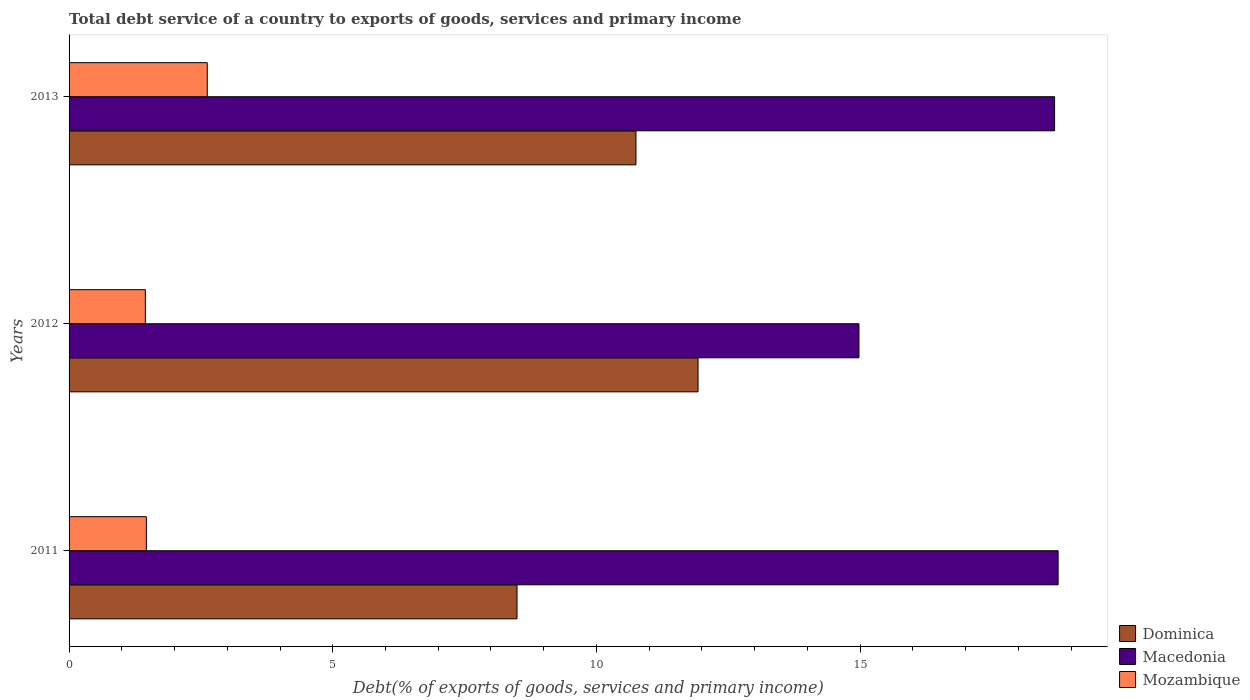How many different coloured bars are there?
Your answer should be very brief. 3. How many groups of bars are there?
Offer a very short reply. 3. Are the number of bars on each tick of the Y-axis equal?
Provide a succinct answer. Yes. What is the total debt service in Mozambique in 2011?
Offer a terse response. 1.47. Across all years, what is the maximum total debt service in Mozambique?
Offer a very short reply. 2.62. Across all years, what is the minimum total debt service in Dominica?
Your response must be concise. 8.49. In which year was the total debt service in Macedonia maximum?
Ensure brevity in your answer.  2011. What is the total total debt service in Mozambique in the graph?
Your answer should be very brief. 5.53. What is the difference between the total debt service in Dominica in 2011 and that in 2012?
Your answer should be compact. -3.43. What is the difference between the total debt service in Dominica in 2011 and the total debt service in Mozambique in 2012?
Your response must be concise. 7.05. What is the average total debt service in Macedonia per year?
Offer a terse response. 17.47. In the year 2013, what is the difference between the total debt service in Dominica and total debt service in Macedonia?
Your answer should be very brief. -7.94. What is the ratio of the total debt service in Macedonia in 2011 to that in 2012?
Ensure brevity in your answer.  1.25. Is the total debt service in Macedonia in 2011 less than that in 2013?
Offer a very short reply. No. Is the difference between the total debt service in Dominica in 2011 and 2013 greater than the difference between the total debt service in Macedonia in 2011 and 2013?
Provide a short and direct response. No. What is the difference between the highest and the second highest total debt service in Macedonia?
Give a very brief answer. 0.07. What is the difference between the highest and the lowest total debt service in Macedonia?
Keep it short and to the point. 3.78. Is the sum of the total debt service in Dominica in 2012 and 2013 greater than the maximum total debt service in Mozambique across all years?
Keep it short and to the point. Yes. What does the 1st bar from the top in 2012 represents?
Offer a very short reply. Mozambique. What does the 1st bar from the bottom in 2012 represents?
Offer a very short reply. Dominica. Are all the bars in the graph horizontal?
Provide a short and direct response. Yes. Are the values on the major ticks of X-axis written in scientific E-notation?
Keep it short and to the point. No. Does the graph contain any zero values?
Offer a very short reply. No. Does the graph contain grids?
Your answer should be very brief. No. How many legend labels are there?
Provide a short and direct response. 3. What is the title of the graph?
Give a very brief answer. Total debt service of a country to exports of goods, services and primary income. Does "Poland" appear as one of the legend labels in the graph?
Your response must be concise. No. What is the label or title of the X-axis?
Offer a terse response. Debt(% of exports of goods, services and primary income). What is the label or title of the Y-axis?
Provide a short and direct response. Years. What is the Debt(% of exports of goods, services and primary income) in Dominica in 2011?
Make the answer very short. 8.49. What is the Debt(% of exports of goods, services and primary income) of Macedonia in 2011?
Your response must be concise. 18.75. What is the Debt(% of exports of goods, services and primary income) of Mozambique in 2011?
Make the answer very short. 1.47. What is the Debt(% of exports of goods, services and primary income) in Dominica in 2012?
Give a very brief answer. 11.93. What is the Debt(% of exports of goods, services and primary income) of Macedonia in 2012?
Your response must be concise. 14.98. What is the Debt(% of exports of goods, services and primary income) in Mozambique in 2012?
Offer a very short reply. 1.45. What is the Debt(% of exports of goods, services and primary income) of Dominica in 2013?
Your answer should be compact. 10.75. What is the Debt(% of exports of goods, services and primary income) of Macedonia in 2013?
Your answer should be very brief. 18.69. What is the Debt(% of exports of goods, services and primary income) of Mozambique in 2013?
Your answer should be very brief. 2.62. Across all years, what is the maximum Debt(% of exports of goods, services and primary income) in Dominica?
Make the answer very short. 11.93. Across all years, what is the maximum Debt(% of exports of goods, services and primary income) of Macedonia?
Your response must be concise. 18.75. Across all years, what is the maximum Debt(% of exports of goods, services and primary income) of Mozambique?
Make the answer very short. 2.62. Across all years, what is the minimum Debt(% of exports of goods, services and primary income) in Dominica?
Offer a terse response. 8.49. Across all years, what is the minimum Debt(% of exports of goods, services and primary income) in Macedonia?
Your answer should be very brief. 14.98. Across all years, what is the minimum Debt(% of exports of goods, services and primary income) in Mozambique?
Your response must be concise. 1.45. What is the total Debt(% of exports of goods, services and primary income) of Dominica in the graph?
Offer a very short reply. 31.17. What is the total Debt(% of exports of goods, services and primary income) in Macedonia in the graph?
Keep it short and to the point. 52.42. What is the total Debt(% of exports of goods, services and primary income) in Mozambique in the graph?
Ensure brevity in your answer.  5.53. What is the difference between the Debt(% of exports of goods, services and primary income) of Dominica in 2011 and that in 2012?
Provide a short and direct response. -3.43. What is the difference between the Debt(% of exports of goods, services and primary income) of Macedonia in 2011 and that in 2012?
Your answer should be very brief. 3.78. What is the difference between the Debt(% of exports of goods, services and primary income) of Mozambique in 2011 and that in 2012?
Offer a very short reply. 0.02. What is the difference between the Debt(% of exports of goods, services and primary income) of Dominica in 2011 and that in 2013?
Your response must be concise. -2.26. What is the difference between the Debt(% of exports of goods, services and primary income) of Macedonia in 2011 and that in 2013?
Your answer should be compact. 0.07. What is the difference between the Debt(% of exports of goods, services and primary income) of Mozambique in 2011 and that in 2013?
Provide a short and direct response. -1.15. What is the difference between the Debt(% of exports of goods, services and primary income) in Dominica in 2012 and that in 2013?
Offer a very short reply. 1.18. What is the difference between the Debt(% of exports of goods, services and primary income) of Macedonia in 2012 and that in 2013?
Make the answer very short. -3.71. What is the difference between the Debt(% of exports of goods, services and primary income) of Mozambique in 2012 and that in 2013?
Provide a succinct answer. -1.17. What is the difference between the Debt(% of exports of goods, services and primary income) of Dominica in 2011 and the Debt(% of exports of goods, services and primary income) of Macedonia in 2012?
Keep it short and to the point. -6.48. What is the difference between the Debt(% of exports of goods, services and primary income) in Dominica in 2011 and the Debt(% of exports of goods, services and primary income) in Mozambique in 2012?
Make the answer very short. 7.05. What is the difference between the Debt(% of exports of goods, services and primary income) in Macedonia in 2011 and the Debt(% of exports of goods, services and primary income) in Mozambique in 2012?
Ensure brevity in your answer.  17.31. What is the difference between the Debt(% of exports of goods, services and primary income) of Dominica in 2011 and the Debt(% of exports of goods, services and primary income) of Macedonia in 2013?
Your answer should be very brief. -10.19. What is the difference between the Debt(% of exports of goods, services and primary income) of Dominica in 2011 and the Debt(% of exports of goods, services and primary income) of Mozambique in 2013?
Provide a short and direct response. 5.87. What is the difference between the Debt(% of exports of goods, services and primary income) in Macedonia in 2011 and the Debt(% of exports of goods, services and primary income) in Mozambique in 2013?
Your response must be concise. 16.13. What is the difference between the Debt(% of exports of goods, services and primary income) in Dominica in 2012 and the Debt(% of exports of goods, services and primary income) in Macedonia in 2013?
Your answer should be compact. -6.76. What is the difference between the Debt(% of exports of goods, services and primary income) in Dominica in 2012 and the Debt(% of exports of goods, services and primary income) in Mozambique in 2013?
Give a very brief answer. 9.31. What is the difference between the Debt(% of exports of goods, services and primary income) of Macedonia in 2012 and the Debt(% of exports of goods, services and primary income) of Mozambique in 2013?
Provide a succinct answer. 12.36. What is the average Debt(% of exports of goods, services and primary income) in Dominica per year?
Provide a short and direct response. 10.39. What is the average Debt(% of exports of goods, services and primary income) of Macedonia per year?
Give a very brief answer. 17.47. What is the average Debt(% of exports of goods, services and primary income) of Mozambique per year?
Make the answer very short. 1.84. In the year 2011, what is the difference between the Debt(% of exports of goods, services and primary income) of Dominica and Debt(% of exports of goods, services and primary income) of Macedonia?
Give a very brief answer. -10.26. In the year 2011, what is the difference between the Debt(% of exports of goods, services and primary income) of Dominica and Debt(% of exports of goods, services and primary income) of Mozambique?
Your answer should be very brief. 7.03. In the year 2011, what is the difference between the Debt(% of exports of goods, services and primary income) in Macedonia and Debt(% of exports of goods, services and primary income) in Mozambique?
Provide a succinct answer. 17.29. In the year 2012, what is the difference between the Debt(% of exports of goods, services and primary income) of Dominica and Debt(% of exports of goods, services and primary income) of Macedonia?
Offer a very short reply. -3.05. In the year 2012, what is the difference between the Debt(% of exports of goods, services and primary income) of Dominica and Debt(% of exports of goods, services and primary income) of Mozambique?
Your response must be concise. 10.48. In the year 2012, what is the difference between the Debt(% of exports of goods, services and primary income) of Macedonia and Debt(% of exports of goods, services and primary income) of Mozambique?
Ensure brevity in your answer.  13.53. In the year 2013, what is the difference between the Debt(% of exports of goods, services and primary income) of Dominica and Debt(% of exports of goods, services and primary income) of Macedonia?
Provide a short and direct response. -7.94. In the year 2013, what is the difference between the Debt(% of exports of goods, services and primary income) in Dominica and Debt(% of exports of goods, services and primary income) in Mozambique?
Offer a very short reply. 8.13. In the year 2013, what is the difference between the Debt(% of exports of goods, services and primary income) in Macedonia and Debt(% of exports of goods, services and primary income) in Mozambique?
Keep it short and to the point. 16.07. What is the ratio of the Debt(% of exports of goods, services and primary income) in Dominica in 2011 to that in 2012?
Ensure brevity in your answer.  0.71. What is the ratio of the Debt(% of exports of goods, services and primary income) in Macedonia in 2011 to that in 2012?
Your answer should be compact. 1.25. What is the ratio of the Debt(% of exports of goods, services and primary income) in Mozambique in 2011 to that in 2012?
Make the answer very short. 1.01. What is the ratio of the Debt(% of exports of goods, services and primary income) of Dominica in 2011 to that in 2013?
Offer a very short reply. 0.79. What is the ratio of the Debt(% of exports of goods, services and primary income) in Mozambique in 2011 to that in 2013?
Offer a terse response. 0.56. What is the ratio of the Debt(% of exports of goods, services and primary income) of Dominica in 2012 to that in 2013?
Ensure brevity in your answer.  1.11. What is the ratio of the Debt(% of exports of goods, services and primary income) in Macedonia in 2012 to that in 2013?
Make the answer very short. 0.8. What is the ratio of the Debt(% of exports of goods, services and primary income) of Mozambique in 2012 to that in 2013?
Provide a succinct answer. 0.55. What is the difference between the highest and the second highest Debt(% of exports of goods, services and primary income) in Dominica?
Provide a succinct answer. 1.18. What is the difference between the highest and the second highest Debt(% of exports of goods, services and primary income) in Macedonia?
Make the answer very short. 0.07. What is the difference between the highest and the second highest Debt(% of exports of goods, services and primary income) in Mozambique?
Make the answer very short. 1.15. What is the difference between the highest and the lowest Debt(% of exports of goods, services and primary income) of Dominica?
Keep it short and to the point. 3.43. What is the difference between the highest and the lowest Debt(% of exports of goods, services and primary income) of Macedonia?
Make the answer very short. 3.78. What is the difference between the highest and the lowest Debt(% of exports of goods, services and primary income) of Mozambique?
Provide a short and direct response. 1.17. 